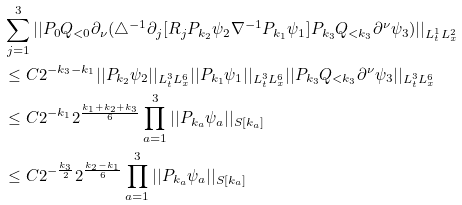<formula> <loc_0><loc_0><loc_500><loc_500>& \sum _ { j = 1 } ^ { 3 } | | P _ { 0 } Q _ { < 0 } \partial _ { \nu } ( \triangle ^ { - 1 } \partial _ { j } [ R _ { j } P _ { k _ { 2 } } \psi _ { 2 } \nabla ^ { - 1 } P _ { k _ { 1 } } \psi _ { 1 } ] P _ { k _ { 3 } } Q _ { < k _ { 3 } } \partial ^ { \nu } \psi _ { 3 } ) | | _ { L _ { t } ^ { 1 } L _ { x } ^ { 2 } } \\ & \leq C 2 ^ { - k _ { 3 } - k _ { 1 } } | | P _ { k _ { 2 } } \psi _ { 2 } | | _ { L _ { t } ^ { 3 } L _ { x } ^ { 6 } } | | P _ { k _ { 1 } } \psi _ { 1 } | | _ { L _ { t } ^ { 3 } L _ { x } ^ { 6 } } | | P _ { k _ { 3 } } Q _ { < k _ { 3 } } \partial ^ { \nu } \psi _ { 3 } | | _ { L _ { t } ^ { 3 } L _ { x } ^ { 6 } } \\ & \leq C 2 ^ { - k _ { 1 } } 2 ^ { \frac { k _ { 1 } + k _ { 2 } + k _ { 3 } } { 6 } } \prod _ { a = 1 } ^ { 3 } | | P _ { k _ { a } } \psi _ { a } | | _ { S [ k _ { a } ] } \\ & \leq C 2 ^ { - \frac { k _ { 3 } } { 2 } } 2 ^ { \frac { k _ { 2 } - k _ { 1 } } { 6 } } \prod _ { a = 1 } ^ { 3 } | | P _ { k _ { a } } \psi _ { a } | | _ { S [ k _ { a } ] } \\</formula> 